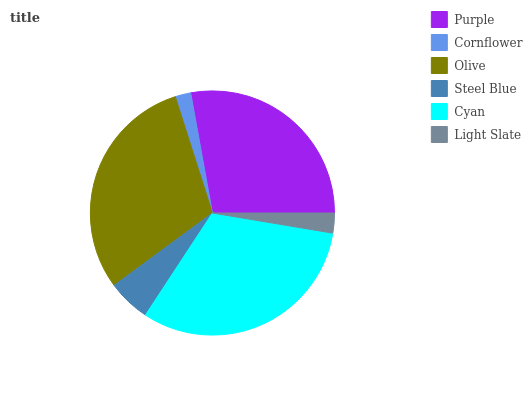Is Cornflower the minimum?
Answer yes or no. Yes. Is Cyan the maximum?
Answer yes or no. Yes. Is Olive the minimum?
Answer yes or no. No. Is Olive the maximum?
Answer yes or no. No. Is Olive greater than Cornflower?
Answer yes or no. Yes. Is Cornflower less than Olive?
Answer yes or no. Yes. Is Cornflower greater than Olive?
Answer yes or no. No. Is Olive less than Cornflower?
Answer yes or no. No. Is Purple the high median?
Answer yes or no. Yes. Is Steel Blue the low median?
Answer yes or no. Yes. Is Cornflower the high median?
Answer yes or no. No. Is Cornflower the low median?
Answer yes or no. No. 